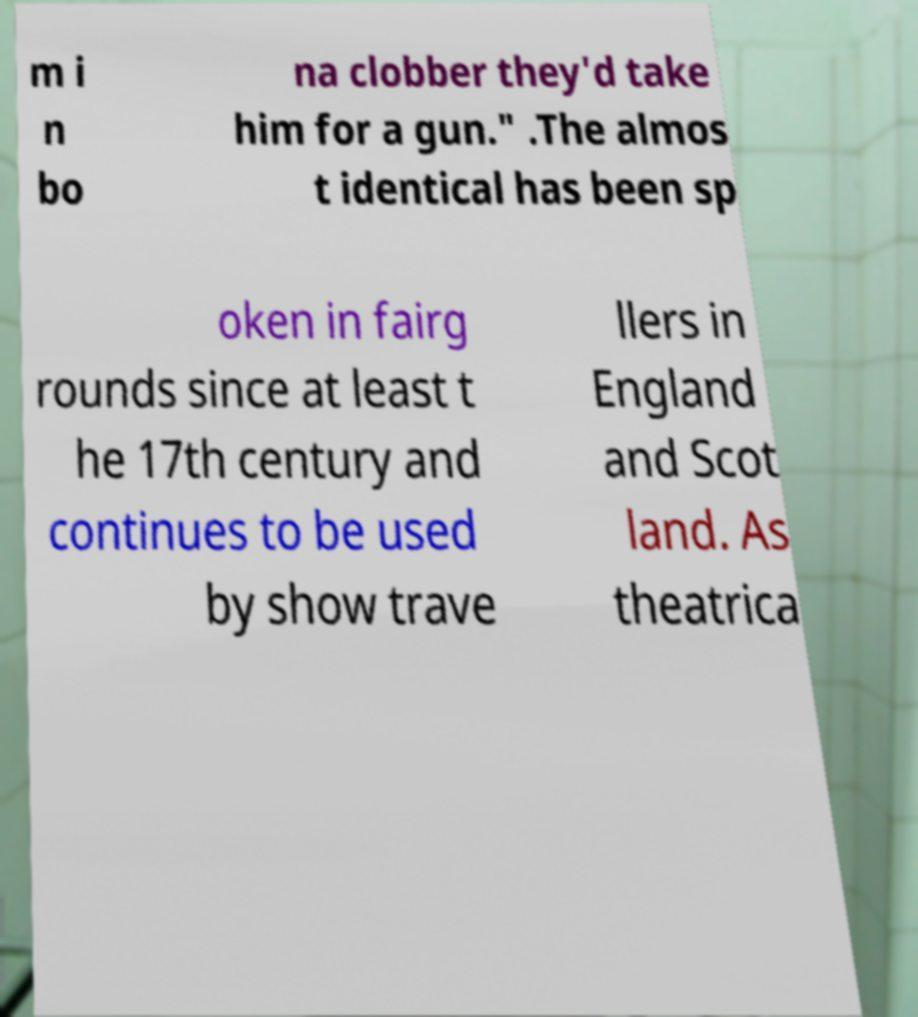Can you read and provide the text displayed in the image?This photo seems to have some interesting text. Can you extract and type it out for me? m i n bo na clobber they'd take him for a gun." .The almos t identical has been sp oken in fairg rounds since at least t he 17th century and continues to be used by show trave llers in England and Scot land. As theatrica 